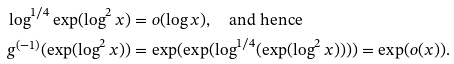Convert formula to latex. <formula><loc_0><loc_0><loc_500><loc_500>\log ^ { 1 / 4 } \exp ( \log ^ { 2 } x ) & = o ( \log x ) , \quad \text {and hence} \\ g ^ { ( - 1 ) } ( \exp ( \log ^ { 2 } x ) ) & = \exp ( \exp ( \log ^ { 1 / 4 } ( \exp ( \log ^ { 2 } x ) ) ) ) = \exp ( o ( x ) ) .</formula> 